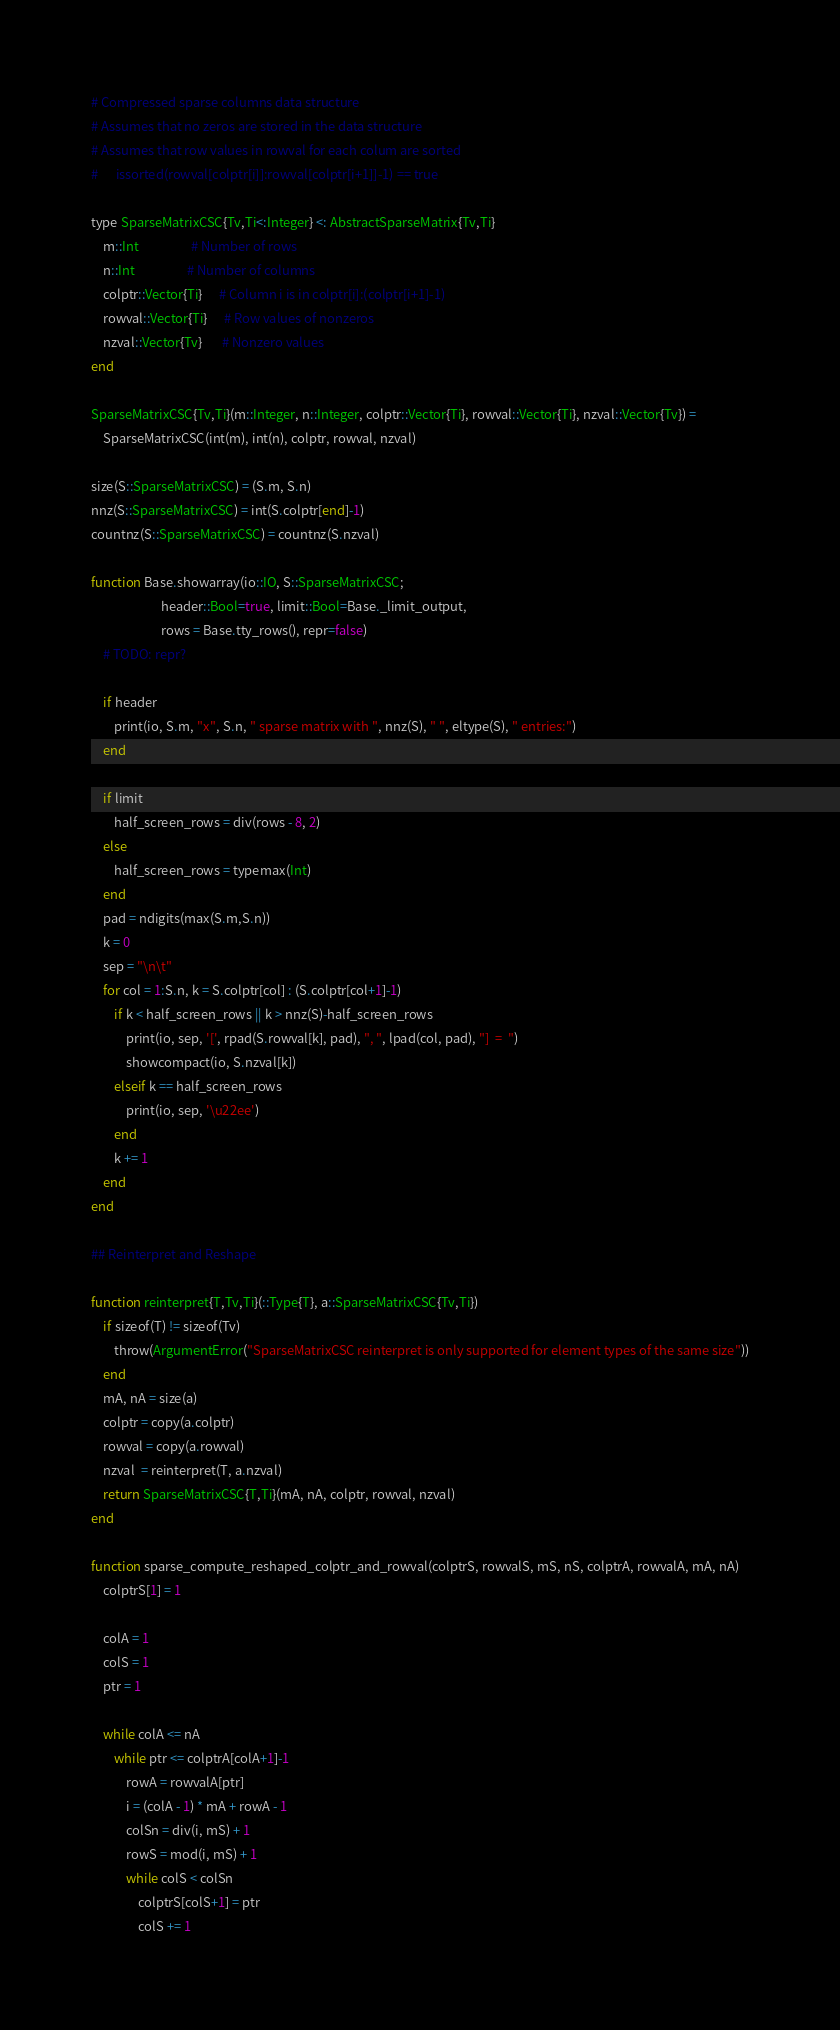Convert code to text. <code><loc_0><loc_0><loc_500><loc_500><_Julia_># Compressed sparse columns data structure
# Assumes that no zeros are stored in the data structure
# Assumes that row values in rowval for each colum are sorted 
#      issorted(rowval[colptr[i]]:rowval[colptr[i+1]]-1) == true

type SparseMatrixCSC{Tv,Ti<:Integer} <: AbstractSparseMatrix{Tv,Ti}
    m::Int                  # Number of rows
    n::Int                  # Number of columns
    colptr::Vector{Ti}      # Column i is in colptr[i]:(colptr[i+1]-1)
    rowval::Vector{Ti}      # Row values of nonzeros
    nzval::Vector{Tv}       # Nonzero values
end

SparseMatrixCSC{Tv,Ti}(m::Integer, n::Integer, colptr::Vector{Ti}, rowval::Vector{Ti}, nzval::Vector{Tv}) =
    SparseMatrixCSC(int(m), int(n), colptr, rowval, nzval)

size(S::SparseMatrixCSC) = (S.m, S.n)
nnz(S::SparseMatrixCSC) = int(S.colptr[end]-1)
countnz(S::SparseMatrixCSC) = countnz(S.nzval)

function Base.showarray(io::IO, S::SparseMatrixCSC;
                        header::Bool=true, limit::Bool=Base._limit_output,
                        rows = Base.tty_rows(), repr=false)
    # TODO: repr?

    if header
        print(io, S.m, "x", S.n, " sparse matrix with ", nnz(S), " ", eltype(S), " entries:")
    end

    if limit
        half_screen_rows = div(rows - 8, 2)
    else
        half_screen_rows = typemax(Int)
    end
    pad = ndigits(max(S.m,S.n))
    k = 0
    sep = "\n\t"
    for col = 1:S.n, k = S.colptr[col] : (S.colptr[col+1]-1)
        if k < half_screen_rows || k > nnz(S)-half_screen_rows
            print(io, sep, '[', rpad(S.rowval[k], pad), ", ", lpad(col, pad), "]  =  ")
            showcompact(io, S.nzval[k])
        elseif k == half_screen_rows
            print(io, sep, '\u22ee')
        end
        k += 1
    end
end

## Reinterpret and Reshape

function reinterpret{T,Tv,Ti}(::Type{T}, a::SparseMatrixCSC{Tv,Ti})
    if sizeof(T) != sizeof(Tv)
        throw(ArgumentError("SparseMatrixCSC reinterpret is only supported for element types of the same size"))
    end
    mA, nA = size(a)
    colptr = copy(a.colptr)
    rowval = copy(a.rowval)
    nzval  = reinterpret(T, a.nzval)
    return SparseMatrixCSC{T,Ti}(mA, nA, colptr, rowval, nzval)
end

function sparse_compute_reshaped_colptr_and_rowval(colptrS, rowvalS, mS, nS, colptrA, rowvalA, mA, nA)
    colptrS[1] = 1

    colA = 1
    colS = 1
    ptr = 1

    while colA <= nA
        while ptr <= colptrA[colA+1]-1
            rowA = rowvalA[ptr]
            i = (colA - 1) * mA + rowA - 1
            colSn = div(i, mS) + 1
            rowS = mod(i, mS) + 1
            while colS < colSn
                colptrS[colS+1] = ptr
                colS += 1</code> 